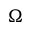Convert formula to latex. <formula><loc_0><loc_0><loc_500><loc_500>\Omega</formula> 